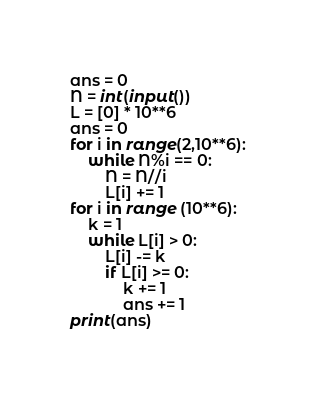<code> <loc_0><loc_0><loc_500><loc_500><_Python_>ans = 0
N = int(input())
L = [0] * 10**6
ans = 0
for i in range(2,10**6):
    while N%i == 0:
        N = N//i
        L[i] += 1
for i in range (10**6):
    k = 1
    while L[i] > 0:
        L[i] -= k
        if L[i] >= 0:
            k += 1
            ans += 1
print(ans)</code> 